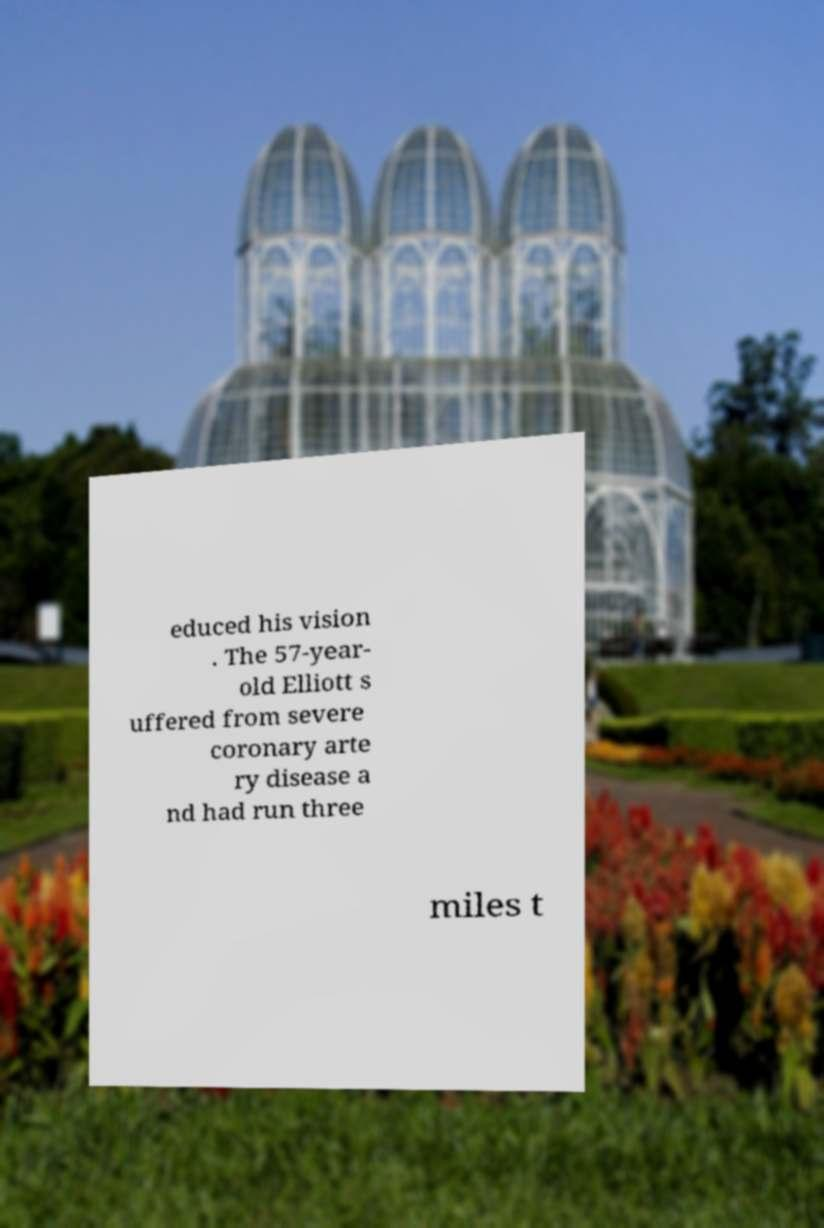There's text embedded in this image that I need extracted. Can you transcribe it verbatim? educed his vision . The 57-year- old Elliott s uffered from severe coronary arte ry disease a nd had run three miles t 